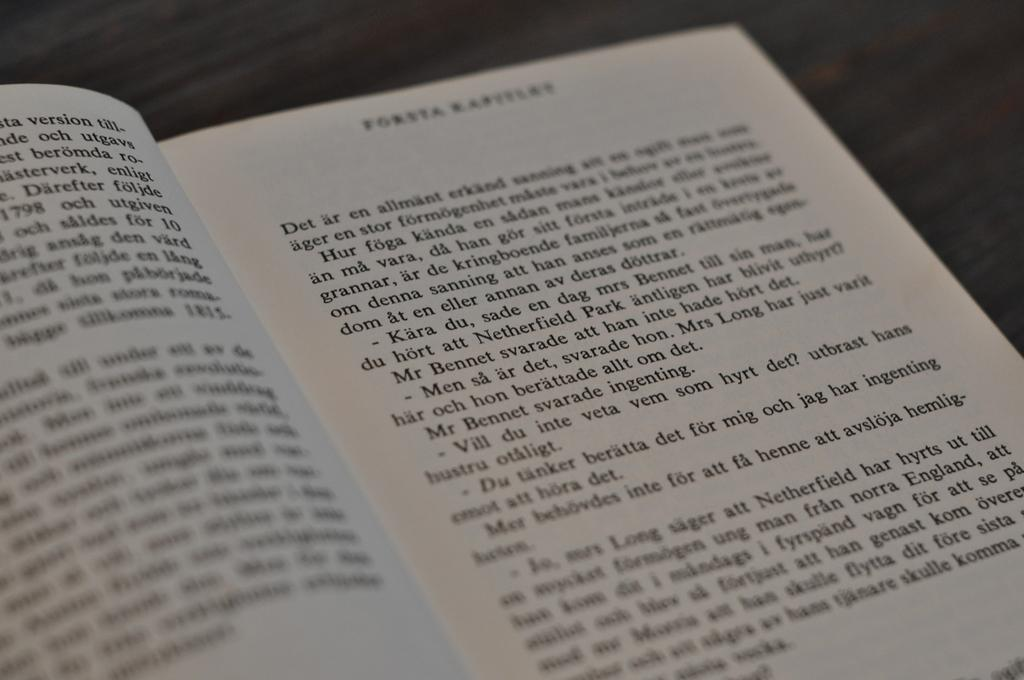What object is visible in the image? There is a book in the image. What is the state of the book in the image? The book is opened. On what surface is the book placed? The book is placed on a wooden surface. Can you see any volcanoes in the image? There are no volcanoes present in the image. What type of observation can be made about the book in the image? The book is opened, which is an observation about its state. --- 